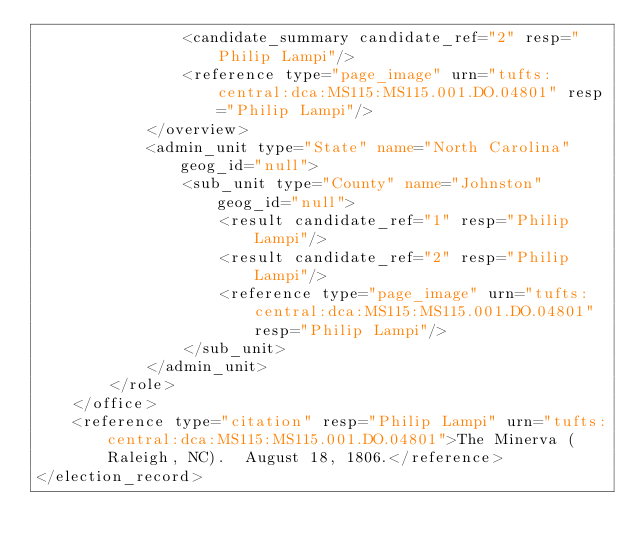<code> <loc_0><loc_0><loc_500><loc_500><_XML_>				<candidate_summary candidate_ref="2" resp="Philip Lampi"/>
				<reference type="page_image" urn="tufts:central:dca:MS115:MS115.001.DO.04801" resp="Philip Lampi"/>
			</overview>
			<admin_unit type="State" name="North Carolina" geog_id="null">
				<sub_unit type="County" name="Johnston" geog_id="null">
					<result candidate_ref="1" resp="Philip Lampi"/>
					<result candidate_ref="2" resp="Philip Lampi"/>
					<reference type="page_image" urn="tufts:central:dca:MS115:MS115.001.DO.04801" resp="Philip Lampi"/>
				</sub_unit>
			</admin_unit>
		</role>
	</office>
	<reference type="citation" resp="Philip Lampi" urn="tufts:central:dca:MS115:MS115.001.DO.04801">The Minerva (Raleigh, NC).  August 18, 1806.</reference>
</election_record>
</code> 